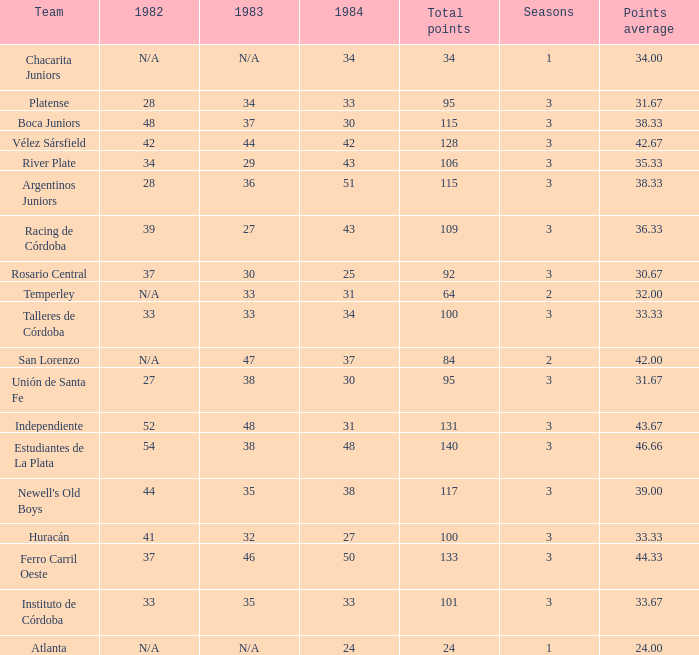What is the total for 1984 for the team with 100 points total and more than 3 seasons? None. 